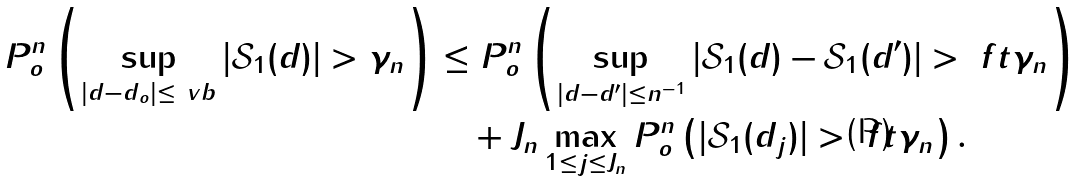<formula> <loc_0><loc_0><loc_500><loc_500>P _ { o } ^ { n } \left ( \sup _ { | d - d _ { o } | \leq \ v b } | \mathcal { S } _ { 1 } ( d ) | > \gamma _ { n } \right ) & \leq P _ { o } ^ { n } \left ( \sup _ { | d - d ^ { \prime } | \leq n ^ { - 1 } } | \mathcal { S } _ { 1 } ( d ) - \mathcal { S } _ { 1 } ( d ^ { \prime } ) | > \ f t \gamma _ { n } \right ) \\ & \quad + J _ { n } \max _ { 1 \leq j \leq J _ { n } } P _ { o } ^ { n } \left ( | \mathcal { S } _ { 1 } ( d _ { j } ) | > \ f t \gamma _ { n } \right ) .</formula> 